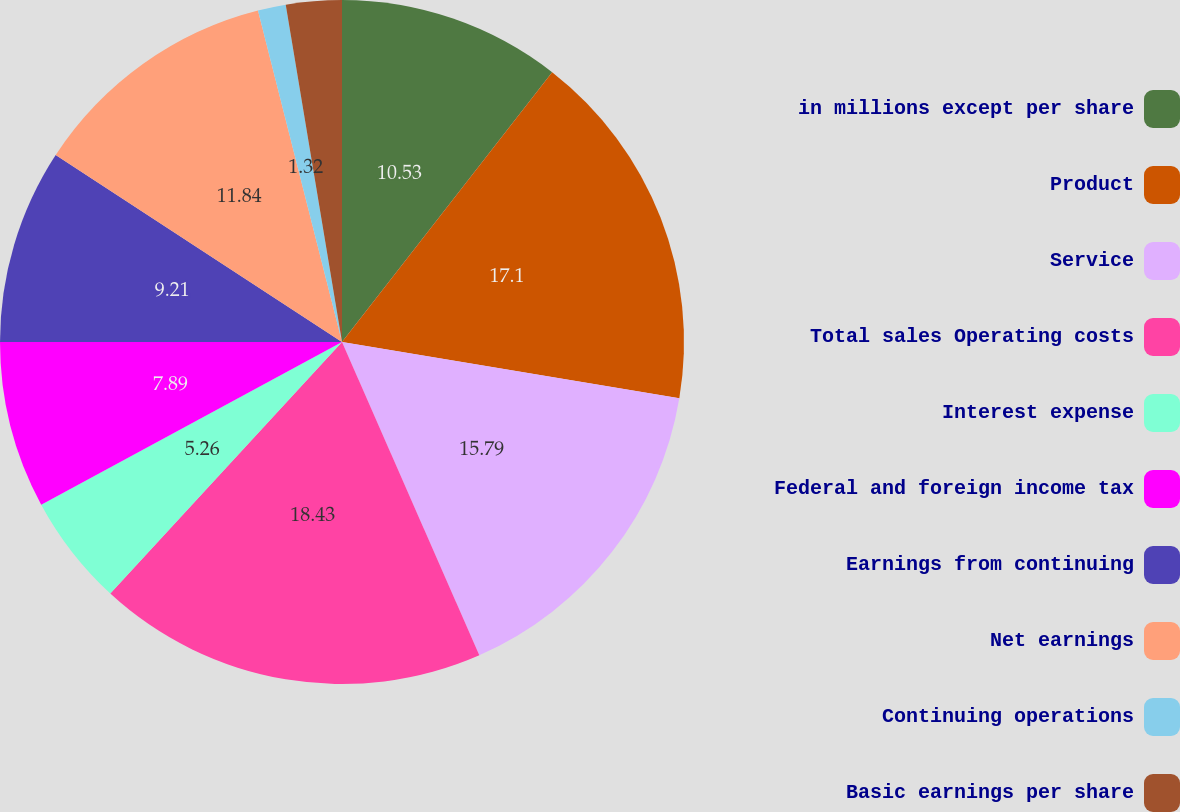Convert chart to OTSL. <chart><loc_0><loc_0><loc_500><loc_500><pie_chart><fcel>in millions except per share<fcel>Product<fcel>Service<fcel>Total sales Operating costs<fcel>Interest expense<fcel>Federal and foreign income tax<fcel>Earnings from continuing<fcel>Net earnings<fcel>Continuing operations<fcel>Basic earnings per share<nl><fcel>10.53%<fcel>17.1%<fcel>15.79%<fcel>18.42%<fcel>5.26%<fcel>7.89%<fcel>9.21%<fcel>11.84%<fcel>1.32%<fcel>2.63%<nl></chart> 